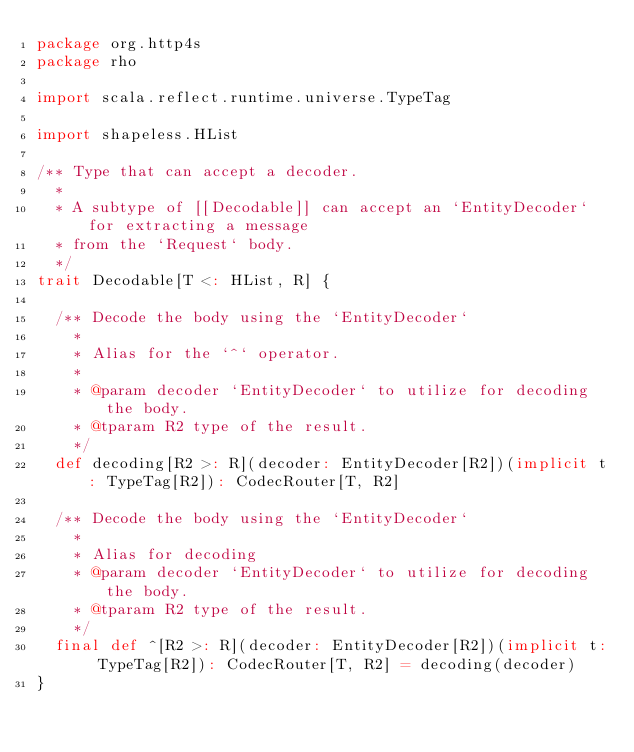<code> <loc_0><loc_0><loc_500><loc_500><_Scala_>package org.http4s
package rho

import scala.reflect.runtime.universe.TypeTag

import shapeless.HList

/** Type that can accept a decoder.
  *
  * A subtype of [[Decodable]] can accept an `EntityDecoder` for extracting a message
  * from the `Request` body.
  */
trait Decodable[T <: HList, R] {

  /** Decode the body using the `EntityDecoder`
    *
    * Alias for the `^` operator.
    *
    * @param decoder `EntityDecoder` to utilize for decoding the body.
    * @tparam R2 type of the result.
    */
  def decoding[R2 >: R](decoder: EntityDecoder[R2])(implicit t: TypeTag[R2]): CodecRouter[T, R2]

  /** Decode the body using the `EntityDecoder`
    *
    * Alias for decoding
    * @param decoder `EntityDecoder` to utilize for decoding the body.
    * @tparam R2 type of the result.
    */
  final def ^[R2 >: R](decoder: EntityDecoder[R2])(implicit t: TypeTag[R2]): CodecRouter[T, R2] = decoding(decoder)
}
</code> 